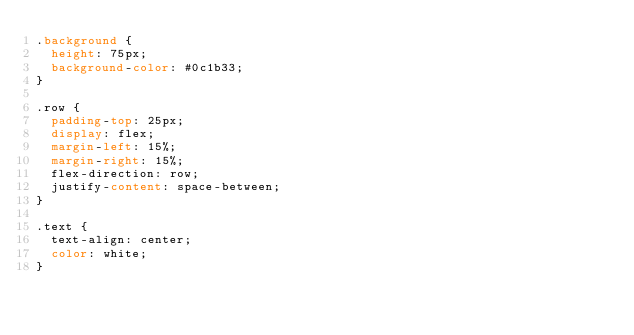Convert code to text. <code><loc_0><loc_0><loc_500><loc_500><_CSS_>.background {
  height: 75px;
  background-color: #0c1b33;
}

.row {
  padding-top: 25px;
  display: flex;
  margin-left: 15%;
  margin-right: 15%;
  flex-direction: row;
  justify-content: space-between;
}

.text {
  text-align: center;
  color: white;
}
</code> 